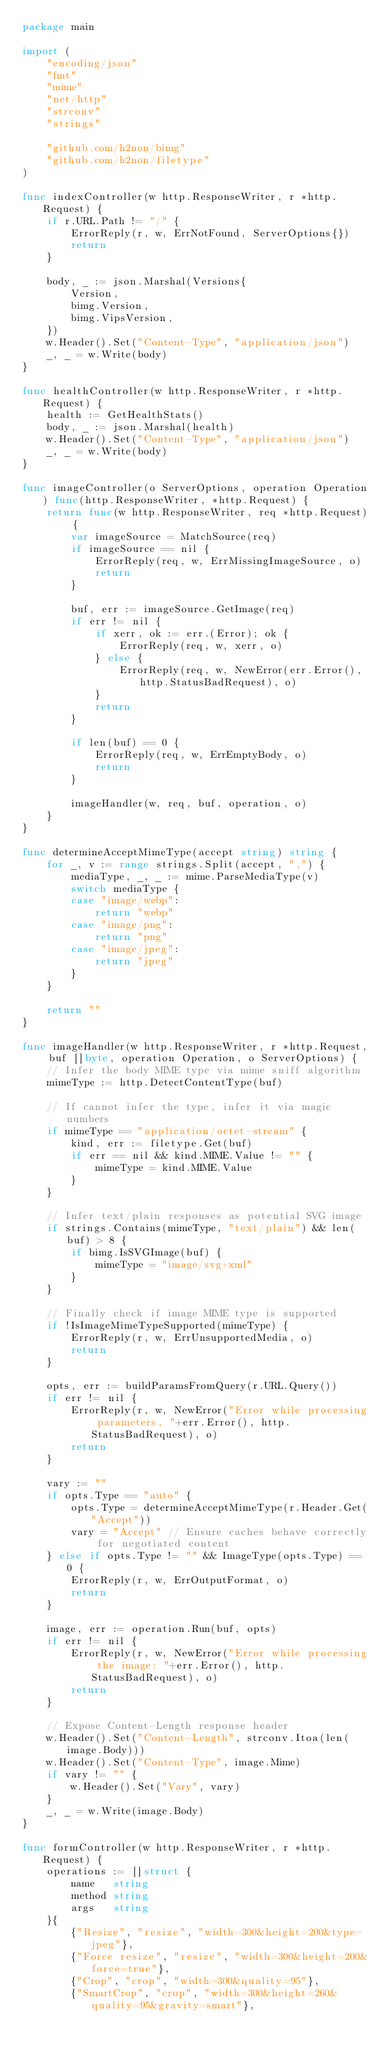Convert code to text. <code><loc_0><loc_0><loc_500><loc_500><_Go_>package main

import (
	"encoding/json"
	"fmt"
	"mime"
	"net/http"
	"strconv"
	"strings"

	"github.com/h2non/bimg"
	"github.com/h2non/filetype"
)

func indexController(w http.ResponseWriter, r *http.Request) {
	if r.URL.Path != "/" {
		ErrorReply(r, w, ErrNotFound, ServerOptions{})
		return
	}

	body, _ := json.Marshal(Versions{
		Version,
		bimg.Version,
		bimg.VipsVersion,
	})
	w.Header().Set("Content-Type", "application/json")
	_, _ = w.Write(body)
}

func healthController(w http.ResponseWriter, r *http.Request) {
	health := GetHealthStats()
	body, _ := json.Marshal(health)
	w.Header().Set("Content-Type", "application/json")
	_, _ = w.Write(body)
}

func imageController(o ServerOptions, operation Operation) func(http.ResponseWriter, *http.Request) {
	return func(w http.ResponseWriter, req *http.Request) {
		var imageSource = MatchSource(req)
		if imageSource == nil {
			ErrorReply(req, w, ErrMissingImageSource, o)
			return
		}

		buf, err := imageSource.GetImage(req)
		if err != nil {
			if xerr, ok := err.(Error); ok {
				ErrorReply(req, w, xerr, o)
			} else {
				ErrorReply(req, w, NewError(err.Error(), http.StatusBadRequest), o)
			}
			return
		}

		if len(buf) == 0 {
			ErrorReply(req, w, ErrEmptyBody, o)
			return
		}

		imageHandler(w, req, buf, operation, o)
	}
}

func determineAcceptMimeType(accept string) string {
	for _, v := range strings.Split(accept, ",") {
		mediaType, _, _ := mime.ParseMediaType(v)
		switch mediaType {
		case "image/webp":
			return "webp"
		case "image/png":
			return "png"
		case "image/jpeg":
			return "jpeg"
		}
	}

	return ""
}

func imageHandler(w http.ResponseWriter, r *http.Request, buf []byte, operation Operation, o ServerOptions) {
	// Infer the body MIME type via mime sniff algorithm
	mimeType := http.DetectContentType(buf)

	// If cannot infer the type, infer it via magic numbers
	if mimeType == "application/octet-stream" {
		kind, err := filetype.Get(buf)
		if err == nil && kind.MIME.Value != "" {
			mimeType = kind.MIME.Value
		}
	}

	// Infer text/plain responses as potential SVG image
	if strings.Contains(mimeType, "text/plain") && len(buf) > 8 {
		if bimg.IsSVGImage(buf) {
			mimeType = "image/svg+xml"
		}
	}

	// Finally check if image MIME type is supported
	if !IsImageMimeTypeSupported(mimeType) {
		ErrorReply(r, w, ErrUnsupportedMedia, o)
		return
	}

	opts, err := buildParamsFromQuery(r.URL.Query())
	if err != nil {
		ErrorReply(r, w, NewError("Error while processing parameters, "+err.Error(), http.StatusBadRequest), o)
		return
	}

	vary := ""
	if opts.Type == "auto" {
		opts.Type = determineAcceptMimeType(r.Header.Get("Accept"))
		vary = "Accept" // Ensure caches behave correctly for negotiated content
	} else if opts.Type != "" && ImageType(opts.Type) == 0 {
		ErrorReply(r, w, ErrOutputFormat, o)
		return
	}

	image, err := operation.Run(buf, opts)
	if err != nil {
		ErrorReply(r, w, NewError("Error while processing the image: "+err.Error(), http.StatusBadRequest), o)
		return
	}

	// Expose Content-Length response header
	w.Header().Set("Content-Length", strconv.Itoa(len(image.Body)))
	w.Header().Set("Content-Type", image.Mime)
	if vary != "" {
		w.Header().Set("Vary", vary)
	}
	_, _ = w.Write(image.Body)
}

func formController(w http.ResponseWriter, r *http.Request) {
	operations := []struct {
		name   string
		method string
		args   string
	}{
		{"Resize", "resize", "width=300&height=200&type=jpeg"},
		{"Force resize", "resize", "width=300&height=200&force=true"},
		{"Crop", "crop", "width=300&quality=95"},
		{"SmartCrop", "crop", "width=300&height=260&quality=95&gravity=smart"},</code> 